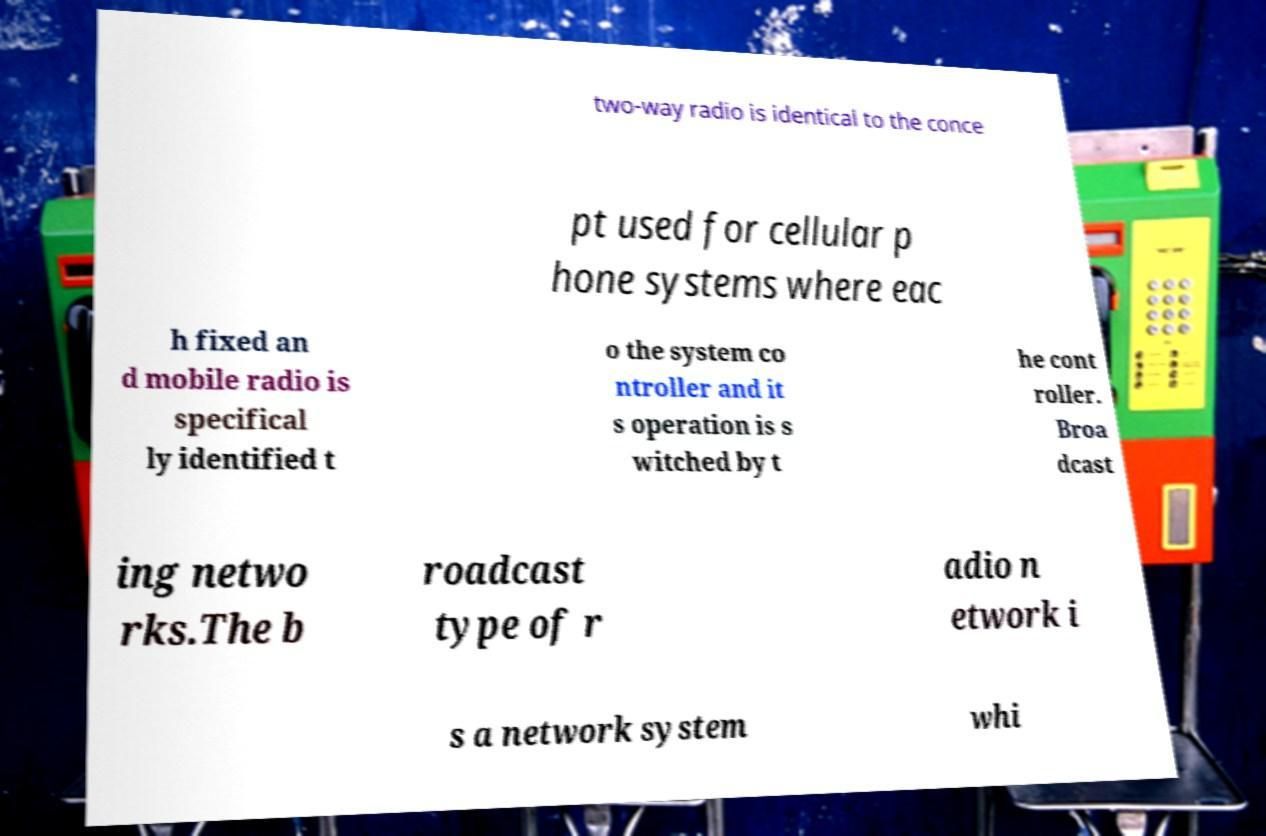Could you assist in decoding the text presented in this image and type it out clearly? two-way radio is identical to the conce pt used for cellular p hone systems where eac h fixed an d mobile radio is specifical ly identified t o the system co ntroller and it s operation is s witched by t he cont roller. Broa dcast ing netwo rks.The b roadcast type of r adio n etwork i s a network system whi 